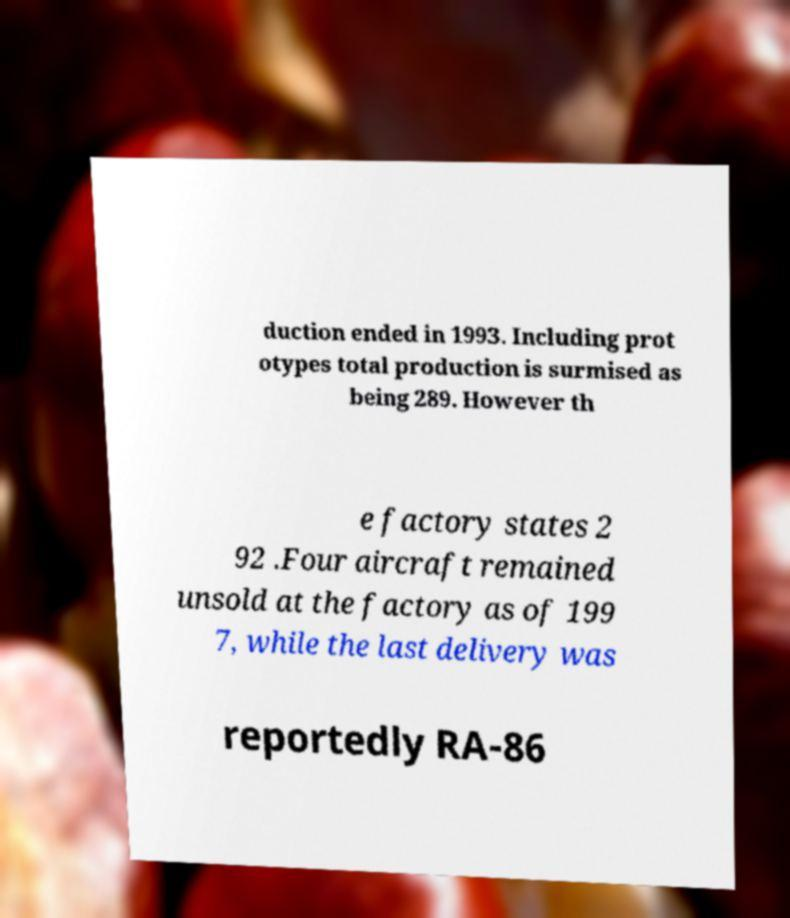Please identify and transcribe the text found in this image. duction ended in 1993. Including prot otypes total production is surmised as being 289. However th e factory states 2 92 .Four aircraft remained unsold at the factory as of 199 7, while the last delivery was reportedly RA-86 